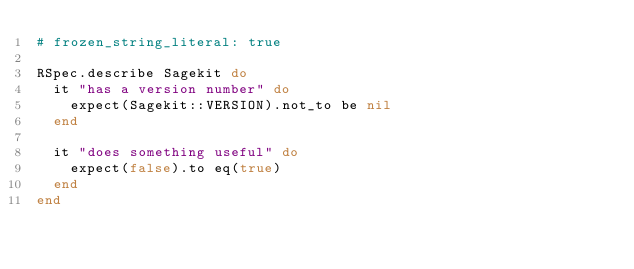<code> <loc_0><loc_0><loc_500><loc_500><_Ruby_># frozen_string_literal: true

RSpec.describe Sagekit do
  it "has a version number" do
    expect(Sagekit::VERSION).not_to be nil
  end

  it "does something useful" do
    expect(false).to eq(true)
  end
end
</code> 